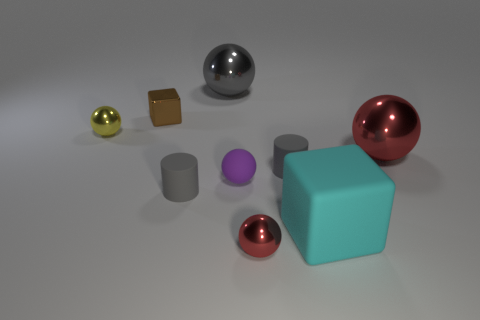Subtract all small matte spheres. How many spheres are left? 4 Subtract all gray spheres. How many spheres are left? 4 Subtract all blue spheres. Subtract all gray cubes. How many spheres are left? 5 Subtract all cylinders. How many objects are left? 7 Add 5 big rubber cubes. How many big rubber cubes are left? 6 Add 4 blue metal objects. How many blue metal objects exist? 4 Subtract 1 yellow spheres. How many objects are left? 8 Subtract all small matte things. Subtract all big yellow blocks. How many objects are left? 6 